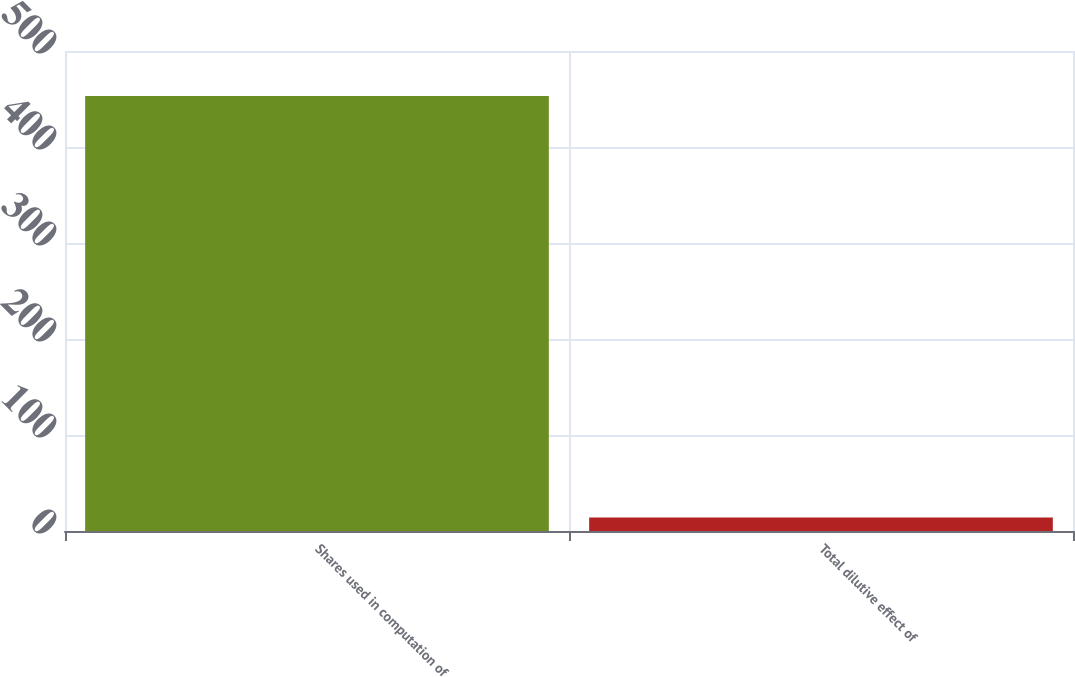<chart> <loc_0><loc_0><loc_500><loc_500><bar_chart><fcel>Shares used in computation of<fcel>Total dilutive effect of<nl><fcel>453.2<fcel>14<nl></chart> 